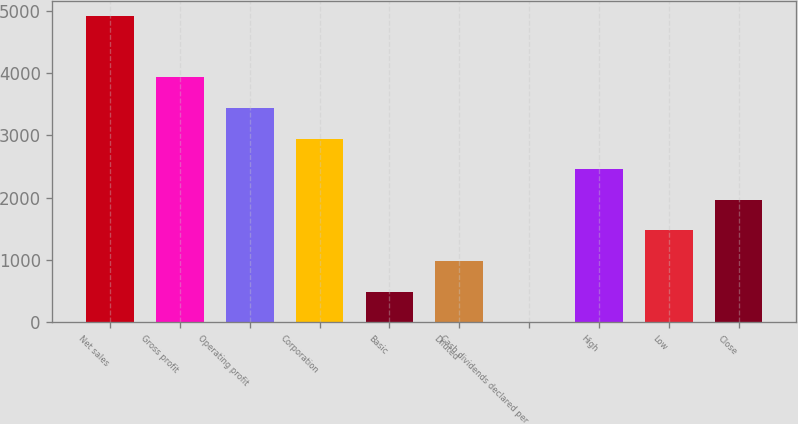<chart> <loc_0><loc_0><loc_500><loc_500><bar_chart><fcel>Net sales<fcel>Gross profit<fcel>Operating profit<fcel>Corporation<fcel>Basic<fcel>Diluted<fcel>Cash dividends declared per<fcel>High<fcel>Low<fcel>Close<nl><fcel>4913<fcel>3930.52<fcel>3439.28<fcel>2948.04<fcel>491.84<fcel>983.08<fcel>0.6<fcel>2456.8<fcel>1474.32<fcel>1965.56<nl></chart> 